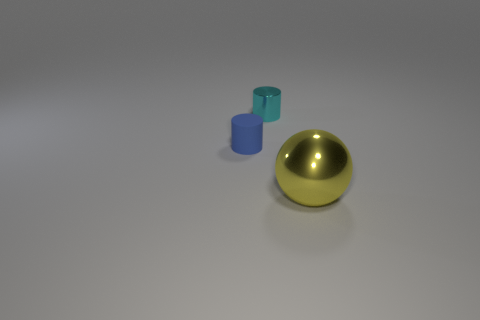Add 1 yellow metal objects. How many objects exist? 4 Subtract all cylinders. How many objects are left? 1 Add 3 cyan objects. How many cyan objects are left? 4 Add 2 tiny objects. How many tiny objects exist? 4 Subtract 0 brown cylinders. How many objects are left? 3 Subtract all tiny red shiny cylinders. Subtract all yellow balls. How many objects are left? 2 